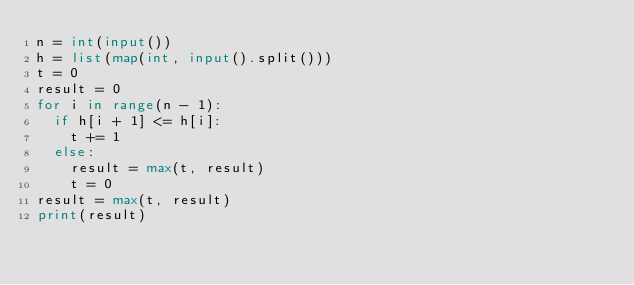Convert code to text. <code><loc_0><loc_0><loc_500><loc_500><_Python_>n = int(input())
h = list(map(int, input().split()))
t = 0
result = 0
for i in range(n - 1):
  if h[i + 1] <= h[i]:
    t += 1
  else:
    result = max(t, result)
    t = 0
result = max(t, result)
print(result)</code> 